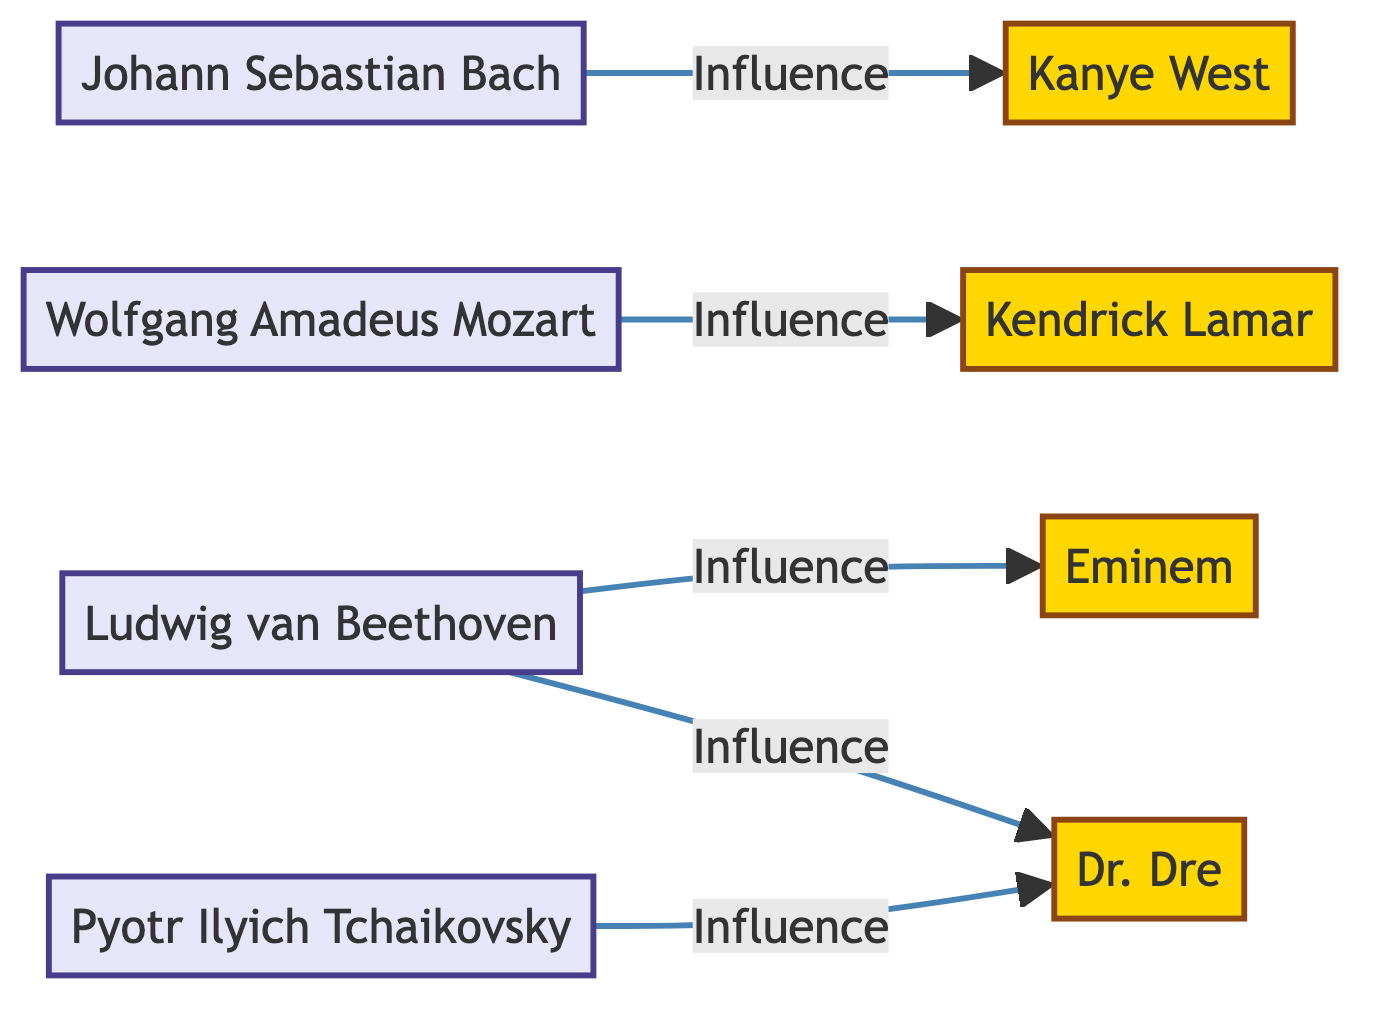What is the total number of nodes in the diagram? The diagram includes eight nodes: four classical composers (Bach, Mozart, Beethoven, Tchaikovsky) and four rap artists (Kanye, Kendrick Lamar, Eminem, Dr. Dre). Therefore, the total is eight nodes.
Answer: 8 Which classical composer has connections to Dr. Dre? In the diagram, both Ludwig van Beethoven and Pyotr Ilyich Tchaikovsky have connections to Dr. Dre, indicated by the "Influence" label on the edges.
Answer: Beethoven, Tchaikovsky How many edges are outgoing from Beethoven? Ludwig van Beethoven has two edges connecting him to other nodes: one to Eminem and another to Dr. Dre, indicating that he influences both artists.
Answer: 2 Who influences Kendrick Lamar? The diagram shows a direct influence from Wolfgang Amadeus Mozart to Kendrick Lamar, as indicated by the edge connection label.
Answer: Mozart Which rap artist is influenced by Johann Sebastian Bach? According to the relationships portrayed in the diagram, Kanye West is connected to Johann Sebastian Bach, showing that Bach has an influence on him.
Answer: Kanye West What is the relationship between Tchaikovsky and Dr. Dre? The diagram presents a direct edge from Tchaikovsky to Dr. Dre labeled "Influence," indicating that Tchaikovsky influences Dr. Dre.
Answer: Influence How many classical composers are represented in the diagram? There are four nodes representing classical composers: Johann Sebastian Bach, Wolfgang Amadeus Mozart, Ludwig van Beethoven, and Pyotr Ilyich Tchaikovsky.
Answer: 4 Which rap artist is influenced by Eminem? The diagram does not show any edges indicating that Eminem influences another artist, therefore he is not shown as influencing any rap artist.
Answer: None 